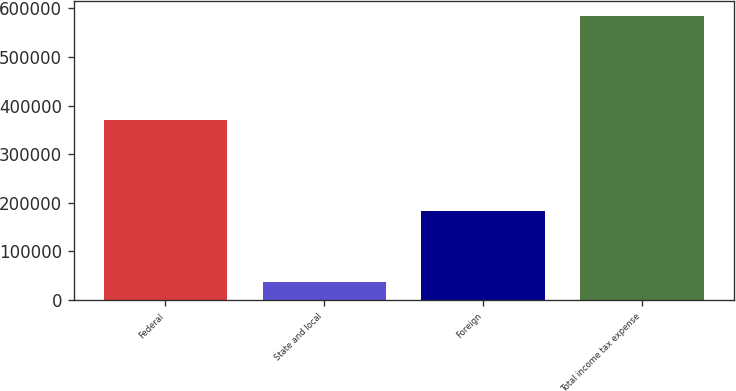Convert chart to OTSL. <chart><loc_0><loc_0><loc_500><loc_500><bar_chart><fcel>Federal<fcel>State and local<fcel>Foreign<fcel>Total income tax expense<nl><fcel>371250<fcel>36661<fcel>183127<fcel>585546<nl></chart> 